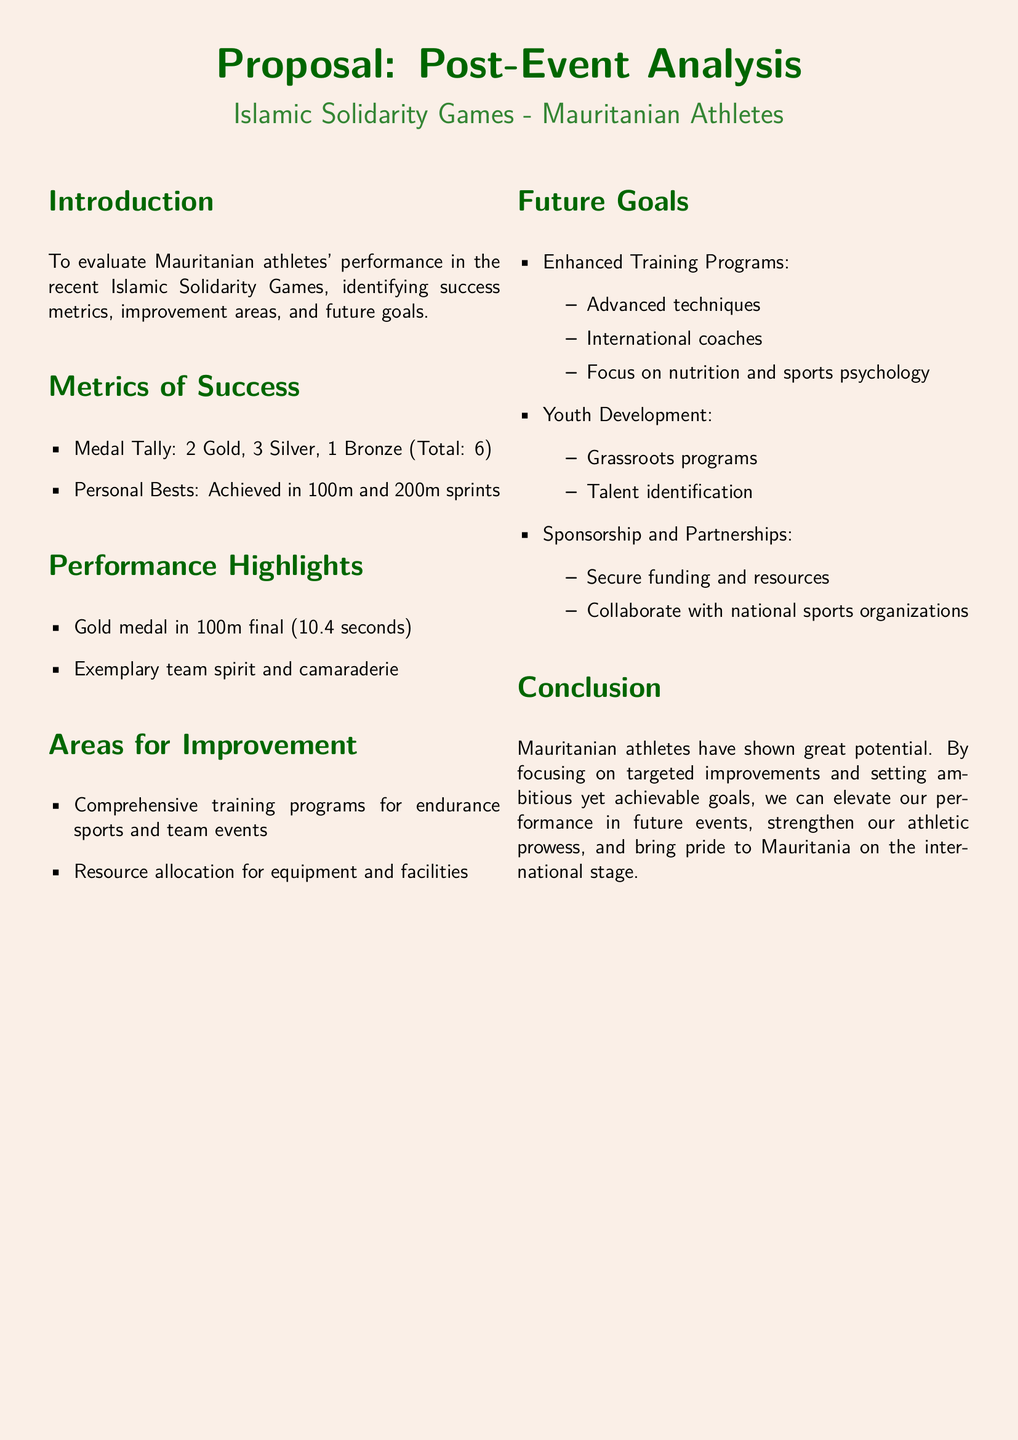What is the total number of medals won by Mauritanian athletes? The document lists the total medals as 2 Gold, 3 Silver, and 1 Bronze, which sums to 6.
Answer: 6 What gold medal event did Mauritanian athletes excel in? The document states that Mauritanian athletes achieved a gold medal in the 100m final.
Answer: 100m final What is one area identified for improvement? The document highlights a need for comprehensive training programs for endurance sports and team events.
Answer: Comprehensive training programs How many personal bests did Mauritanian athletes achieve? The report mentions personal bests achieved in 100m and 200m sprints, which indicates a total of 2.
Answer: 2 What is one of the future goals for Mauritanian athletes? The document outlines enhanced training programs as a key future goal.
Answer: Enhanced Training Programs How many silver medals were won by Mauritanian athletes? According to the document, Mauritanian athletes secured 3 Silver medals.
Answer: 3 What is one metric of success mentioned? The document lists the medal tally as an important metric of success.
Answer: Medal Tally Which aspect of athlete development is emphasized in the future goals? The proposal emphasizes youth development, specifically grassroots programs and talent identification.
Answer: Youth Development What notable performance feature is mentioned in the highlights? The document notes exemplary team spirit and camaraderie as a highlight of performance.
Answer: Team spirit and camaraderie 